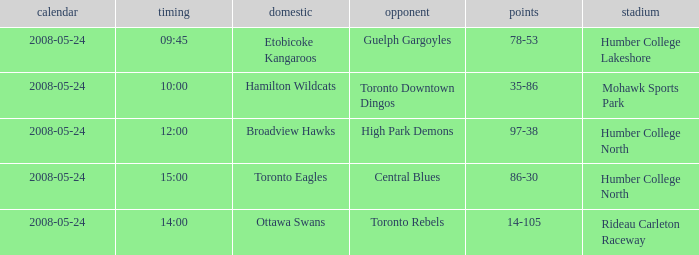What location did the toronto rebels' away team use for their games? Rideau Carleton Raceway. 